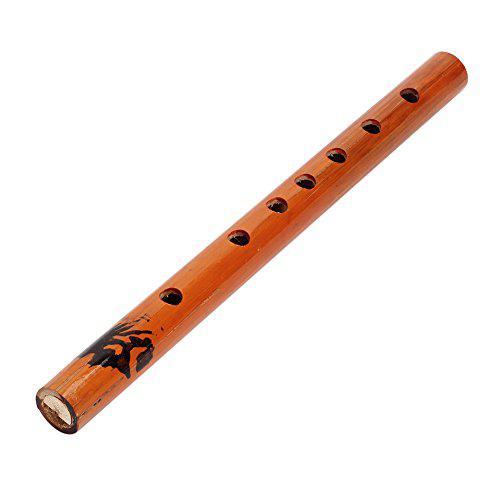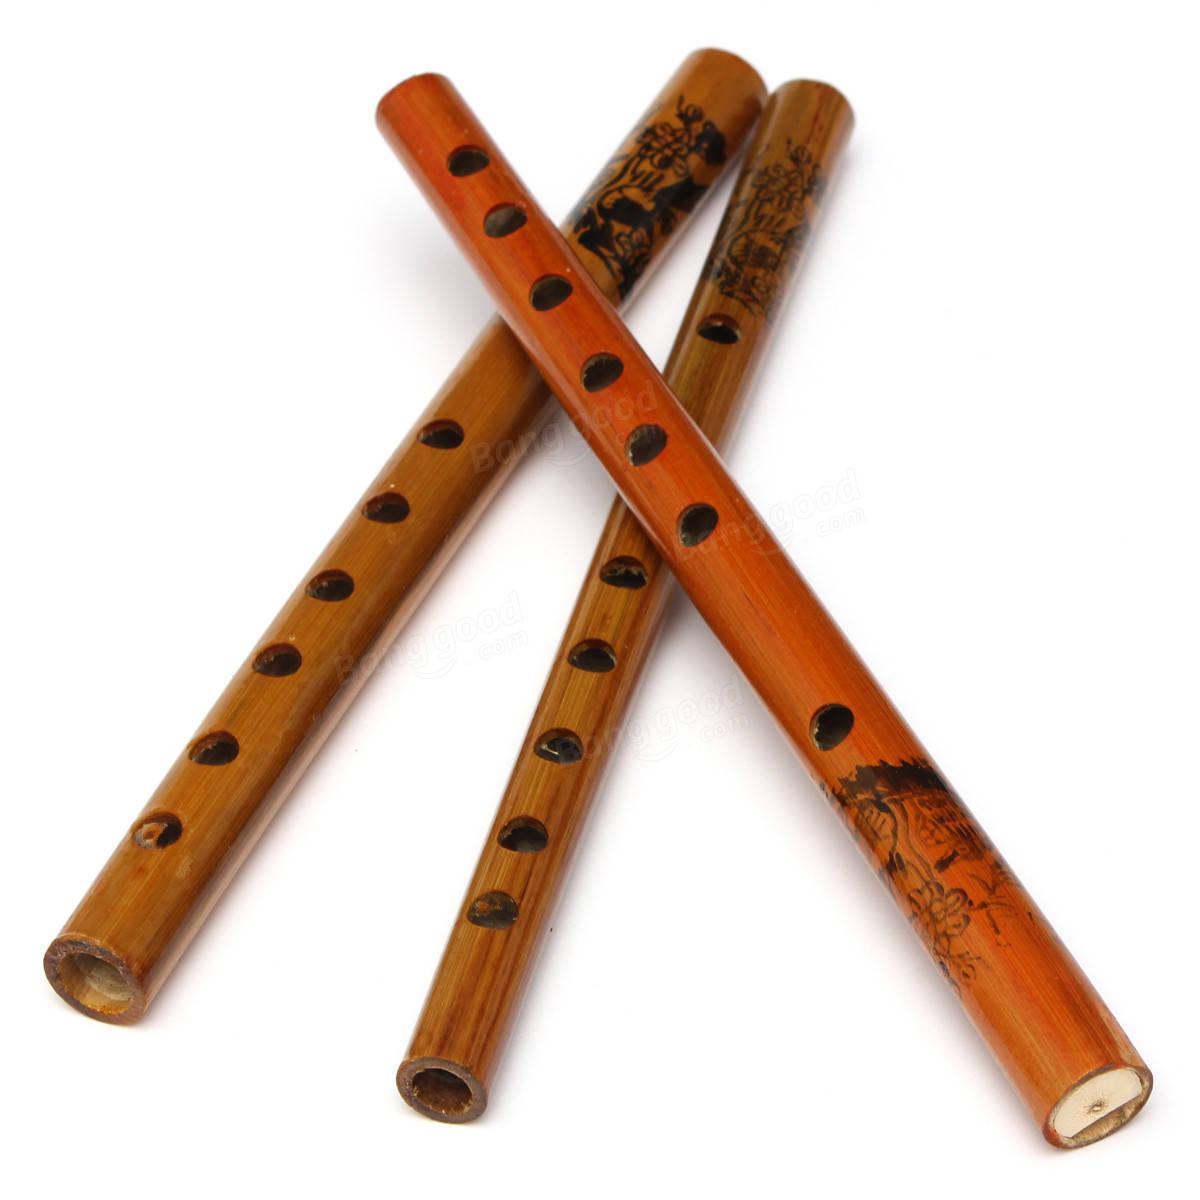The first image is the image on the left, the second image is the image on the right. Analyze the images presented: Is the assertion "One image shows exactly three wooden flutes, and the other image contains at least one flute displayed diagonally." valid? Answer yes or no. Yes. The first image is the image on the left, the second image is the image on the right. Assess this claim about the two images: "Exactly two instruments have black bands.". Correct or not? Answer yes or no. No. 